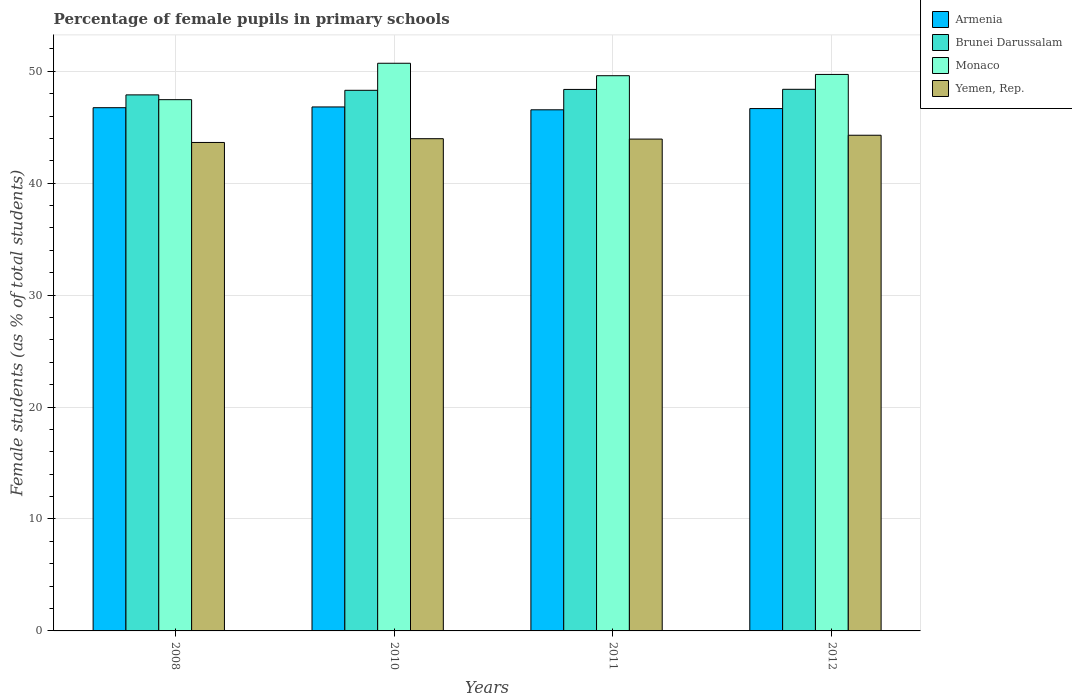How many different coloured bars are there?
Keep it short and to the point. 4. How many groups of bars are there?
Offer a very short reply. 4. Are the number of bars per tick equal to the number of legend labels?
Ensure brevity in your answer.  Yes. How many bars are there on the 4th tick from the left?
Give a very brief answer. 4. How many bars are there on the 3rd tick from the right?
Offer a terse response. 4. What is the label of the 4th group of bars from the left?
Your answer should be compact. 2012. In how many cases, is the number of bars for a given year not equal to the number of legend labels?
Offer a terse response. 0. What is the percentage of female pupils in primary schools in Yemen, Rep. in 2010?
Ensure brevity in your answer.  43.98. Across all years, what is the maximum percentage of female pupils in primary schools in Yemen, Rep.?
Your response must be concise. 44.28. Across all years, what is the minimum percentage of female pupils in primary schools in Monaco?
Offer a very short reply. 47.46. What is the total percentage of female pupils in primary schools in Yemen, Rep. in the graph?
Make the answer very short. 175.84. What is the difference between the percentage of female pupils in primary schools in Monaco in 2010 and that in 2011?
Ensure brevity in your answer.  1.11. What is the difference between the percentage of female pupils in primary schools in Yemen, Rep. in 2010 and the percentage of female pupils in primary schools in Brunei Darussalam in 2012?
Ensure brevity in your answer.  -4.41. What is the average percentage of female pupils in primary schools in Yemen, Rep. per year?
Provide a short and direct response. 43.96. In the year 2008, what is the difference between the percentage of female pupils in primary schools in Brunei Darussalam and percentage of female pupils in primary schools in Monaco?
Give a very brief answer. 0.43. In how many years, is the percentage of female pupils in primary schools in Monaco greater than 14 %?
Provide a short and direct response. 4. What is the ratio of the percentage of female pupils in primary schools in Yemen, Rep. in 2008 to that in 2012?
Give a very brief answer. 0.99. What is the difference between the highest and the second highest percentage of female pupils in primary schools in Monaco?
Give a very brief answer. 1. What is the difference between the highest and the lowest percentage of female pupils in primary schools in Brunei Darussalam?
Your answer should be very brief. 0.5. In how many years, is the percentage of female pupils in primary schools in Monaco greater than the average percentage of female pupils in primary schools in Monaco taken over all years?
Give a very brief answer. 3. What does the 4th bar from the left in 2011 represents?
Keep it short and to the point. Yemen, Rep. What does the 2nd bar from the right in 2011 represents?
Offer a very short reply. Monaco. Is it the case that in every year, the sum of the percentage of female pupils in primary schools in Armenia and percentage of female pupils in primary schools in Yemen, Rep. is greater than the percentage of female pupils in primary schools in Brunei Darussalam?
Your answer should be compact. Yes. How many bars are there?
Your answer should be compact. 16. Does the graph contain grids?
Provide a succinct answer. Yes. How are the legend labels stacked?
Keep it short and to the point. Vertical. What is the title of the graph?
Make the answer very short. Percentage of female pupils in primary schools. Does "Suriname" appear as one of the legend labels in the graph?
Ensure brevity in your answer.  No. What is the label or title of the Y-axis?
Your answer should be compact. Female students (as % of total students). What is the Female students (as % of total students) in Armenia in 2008?
Give a very brief answer. 46.74. What is the Female students (as % of total students) in Brunei Darussalam in 2008?
Offer a terse response. 47.89. What is the Female students (as % of total students) in Monaco in 2008?
Make the answer very short. 47.46. What is the Female students (as % of total students) of Yemen, Rep. in 2008?
Ensure brevity in your answer.  43.64. What is the Female students (as % of total students) of Armenia in 2010?
Offer a very short reply. 46.81. What is the Female students (as % of total students) in Brunei Darussalam in 2010?
Give a very brief answer. 48.3. What is the Female students (as % of total students) of Monaco in 2010?
Provide a short and direct response. 50.71. What is the Female students (as % of total students) in Yemen, Rep. in 2010?
Your response must be concise. 43.98. What is the Female students (as % of total students) in Armenia in 2011?
Give a very brief answer. 46.56. What is the Female students (as % of total students) in Brunei Darussalam in 2011?
Ensure brevity in your answer.  48.38. What is the Female students (as % of total students) in Monaco in 2011?
Ensure brevity in your answer.  49.6. What is the Female students (as % of total students) of Yemen, Rep. in 2011?
Keep it short and to the point. 43.94. What is the Female students (as % of total students) of Armenia in 2012?
Give a very brief answer. 46.67. What is the Female students (as % of total students) in Brunei Darussalam in 2012?
Offer a terse response. 48.39. What is the Female students (as % of total students) in Monaco in 2012?
Your response must be concise. 49.72. What is the Female students (as % of total students) in Yemen, Rep. in 2012?
Provide a short and direct response. 44.28. Across all years, what is the maximum Female students (as % of total students) in Armenia?
Your answer should be very brief. 46.81. Across all years, what is the maximum Female students (as % of total students) of Brunei Darussalam?
Provide a short and direct response. 48.39. Across all years, what is the maximum Female students (as % of total students) of Monaco?
Provide a succinct answer. 50.71. Across all years, what is the maximum Female students (as % of total students) of Yemen, Rep.?
Offer a very short reply. 44.28. Across all years, what is the minimum Female students (as % of total students) in Armenia?
Ensure brevity in your answer.  46.56. Across all years, what is the minimum Female students (as % of total students) of Brunei Darussalam?
Offer a terse response. 47.89. Across all years, what is the minimum Female students (as % of total students) in Monaco?
Ensure brevity in your answer.  47.46. Across all years, what is the minimum Female students (as % of total students) of Yemen, Rep.?
Give a very brief answer. 43.64. What is the total Female students (as % of total students) in Armenia in the graph?
Provide a succinct answer. 186.78. What is the total Female students (as % of total students) in Brunei Darussalam in the graph?
Your response must be concise. 192.95. What is the total Female students (as % of total students) of Monaco in the graph?
Your answer should be compact. 197.5. What is the total Female students (as % of total students) of Yemen, Rep. in the graph?
Provide a succinct answer. 175.84. What is the difference between the Female students (as % of total students) of Armenia in 2008 and that in 2010?
Ensure brevity in your answer.  -0.07. What is the difference between the Female students (as % of total students) of Brunei Darussalam in 2008 and that in 2010?
Make the answer very short. -0.41. What is the difference between the Female students (as % of total students) of Monaco in 2008 and that in 2010?
Keep it short and to the point. -3.25. What is the difference between the Female students (as % of total students) of Yemen, Rep. in 2008 and that in 2010?
Your response must be concise. -0.34. What is the difference between the Female students (as % of total students) of Armenia in 2008 and that in 2011?
Offer a terse response. 0.19. What is the difference between the Female students (as % of total students) of Brunei Darussalam in 2008 and that in 2011?
Keep it short and to the point. -0.49. What is the difference between the Female students (as % of total students) in Monaco in 2008 and that in 2011?
Keep it short and to the point. -2.14. What is the difference between the Female students (as % of total students) in Yemen, Rep. in 2008 and that in 2011?
Your answer should be compact. -0.3. What is the difference between the Female students (as % of total students) of Armenia in 2008 and that in 2012?
Give a very brief answer. 0.08. What is the difference between the Female students (as % of total students) of Brunei Darussalam in 2008 and that in 2012?
Your answer should be very brief. -0.5. What is the difference between the Female students (as % of total students) in Monaco in 2008 and that in 2012?
Make the answer very short. -2.25. What is the difference between the Female students (as % of total students) in Yemen, Rep. in 2008 and that in 2012?
Your answer should be compact. -0.65. What is the difference between the Female students (as % of total students) in Armenia in 2010 and that in 2011?
Your answer should be compact. 0.26. What is the difference between the Female students (as % of total students) in Brunei Darussalam in 2010 and that in 2011?
Your answer should be very brief. -0.08. What is the difference between the Female students (as % of total students) in Monaco in 2010 and that in 2011?
Keep it short and to the point. 1.11. What is the difference between the Female students (as % of total students) of Yemen, Rep. in 2010 and that in 2011?
Provide a succinct answer. 0.04. What is the difference between the Female students (as % of total students) in Armenia in 2010 and that in 2012?
Your answer should be compact. 0.15. What is the difference between the Female students (as % of total students) in Brunei Darussalam in 2010 and that in 2012?
Provide a short and direct response. -0.09. What is the difference between the Female students (as % of total students) in Yemen, Rep. in 2010 and that in 2012?
Provide a succinct answer. -0.31. What is the difference between the Female students (as % of total students) of Armenia in 2011 and that in 2012?
Offer a very short reply. -0.11. What is the difference between the Female students (as % of total students) in Brunei Darussalam in 2011 and that in 2012?
Provide a short and direct response. -0.01. What is the difference between the Female students (as % of total students) of Monaco in 2011 and that in 2012?
Give a very brief answer. -0.11. What is the difference between the Female students (as % of total students) of Yemen, Rep. in 2011 and that in 2012?
Provide a short and direct response. -0.34. What is the difference between the Female students (as % of total students) of Armenia in 2008 and the Female students (as % of total students) of Brunei Darussalam in 2010?
Your answer should be very brief. -1.55. What is the difference between the Female students (as % of total students) in Armenia in 2008 and the Female students (as % of total students) in Monaco in 2010?
Your response must be concise. -3.97. What is the difference between the Female students (as % of total students) of Armenia in 2008 and the Female students (as % of total students) of Yemen, Rep. in 2010?
Your answer should be very brief. 2.77. What is the difference between the Female students (as % of total students) of Brunei Darussalam in 2008 and the Female students (as % of total students) of Monaco in 2010?
Your response must be concise. -2.83. What is the difference between the Female students (as % of total students) in Brunei Darussalam in 2008 and the Female students (as % of total students) in Yemen, Rep. in 2010?
Offer a very short reply. 3.91. What is the difference between the Female students (as % of total students) in Monaco in 2008 and the Female students (as % of total students) in Yemen, Rep. in 2010?
Your answer should be very brief. 3.49. What is the difference between the Female students (as % of total students) of Armenia in 2008 and the Female students (as % of total students) of Brunei Darussalam in 2011?
Provide a succinct answer. -1.63. What is the difference between the Female students (as % of total students) in Armenia in 2008 and the Female students (as % of total students) in Monaco in 2011?
Make the answer very short. -2.86. What is the difference between the Female students (as % of total students) in Armenia in 2008 and the Female students (as % of total students) in Yemen, Rep. in 2011?
Make the answer very short. 2.8. What is the difference between the Female students (as % of total students) in Brunei Darussalam in 2008 and the Female students (as % of total students) in Monaco in 2011?
Give a very brief answer. -1.71. What is the difference between the Female students (as % of total students) in Brunei Darussalam in 2008 and the Female students (as % of total students) in Yemen, Rep. in 2011?
Provide a short and direct response. 3.95. What is the difference between the Female students (as % of total students) in Monaco in 2008 and the Female students (as % of total students) in Yemen, Rep. in 2011?
Provide a succinct answer. 3.52. What is the difference between the Female students (as % of total students) in Armenia in 2008 and the Female students (as % of total students) in Brunei Darussalam in 2012?
Ensure brevity in your answer.  -1.64. What is the difference between the Female students (as % of total students) in Armenia in 2008 and the Female students (as % of total students) in Monaco in 2012?
Make the answer very short. -2.97. What is the difference between the Female students (as % of total students) of Armenia in 2008 and the Female students (as % of total students) of Yemen, Rep. in 2012?
Your answer should be compact. 2.46. What is the difference between the Female students (as % of total students) of Brunei Darussalam in 2008 and the Female students (as % of total students) of Monaco in 2012?
Your response must be concise. -1.83. What is the difference between the Female students (as % of total students) of Brunei Darussalam in 2008 and the Female students (as % of total students) of Yemen, Rep. in 2012?
Make the answer very short. 3.61. What is the difference between the Female students (as % of total students) of Monaco in 2008 and the Female students (as % of total students) of Yemen, Rep. in 2012?
Your response must be concise. 3.18. What is the difference between the Female students (as % of total students) of Armenia in 2010 and the Female students (as % of total students) of Brunei Darussalam in 2011?
Provide a succinct answer. -1.57. What is the difference between the Female students (as % of total students) in Armenia in 2010 and the Female students (as % of total students) in Monaco in 2011?
Your response must be concise. -2.79. What is the difference between the Female students (as % of total students) in Armenia in 2010 and the Female students (as % of total students) in Yemen, Rep. in 2011?
Offer a terse response. 2.87. What is the difference between the Female students (as % of total students) of Brunei Darussalam in 2010 and the Female students (as % of total students) of Monaco in 2011?
Keep it short and to the point. -1.3. What is the difference between the Female students (as % of total students) in Brunei Darussalam in 2010 and the Female students (as % of total students) in Yemen, Rep. in 2011?
Keep it short and to the point. 4.36. What is the difference between the Female students (as % of total students) of Monaco in 2010 and the Female students (as % of total students) of Yemen, Rep. in 2011?
Your answer should be compact. 6.77. What is the difference between the Female students (as % of total students) of Armenia in 2010 and the Female students (as % of total students) of Brunei Darussalam in 2012?
Give a very brief answer. -1.58. What is the difference between the Female students (as % of total students) in Armenia in 2010 and the Female students (as % of total students) in Monaco in 2012?
Your answer should be very brief. -2.91. What is the difference between the Female students (as % of total students) in Armenia in 2010 and the Female students (as % of total students) in Yemen, Rep. in 2012?
Provide a succinct answer. 2.53. What is the difference between the Female students (as % of total students) of Brunei Darussalam in 2010 and the Female students (as % of total students) of Monaco in 2012?
Your answer should be compact. -1.42. What is the difference between the Female students (as % of total students) in Brunei Darussalam in 2010 and the Female students (as % of total students) in Yemen, Rep. in 2012?
Keep it short and to the point. 4.01. What is the difference between the Female students (as % of total students) in Monaco in 2010 and the Female students (as % of total students) in Yemen, Rep. in 2012?
Offer a very short reply. 6.43. What is the difference between the Female students (as % of total students) of Armenia in 2011 and the Female students (as % of total students) of Brunei Darussalam in 2012?
Give a very brief answer. -1.83. What is the difference between the Female students (as % of total students) in Armenia in 2011 and the Female students (as % of total students) in Monaco in 2012?
Provide a short and direct response. -3.16. What is the difference between the Female students (as % of total students) in Armenia in 2011 and the Female students (as % of total students) in Yemen, Rep. in 2012?
Your answer should be compact. 2.27. What is the difference between the Female students (as % of total students) in Brunei Darussalam in 2011 and the Female students (as % of total students) in Monaco in 2012?
Make the answer very short. -1.34. What is the difference between the Female students (as % of total students) in Brunei Darussalam in 2011 and the Female students (as % of total students) in Yemen, Rep. in 2012?
Offer a terse response. 4.09. What is the difference between the Female students (as % of total students) of Monaco in 2011 and the Female students (as % of total students) of Yemen, Rep. in 2012?
Your answer should be very brief. 5.32. What is the average Female students (as % of total students) of Armenia per year?
Offer a very short reply. 46.69. What is the average Female students (as % of total students) of Brunei Darussalam per year?
Keep it short and to the point. 48.24. What is the average Female students (as % of total students) of Monaco per year?
Keep it short and to the point. 49.37. What is the average Female students (as % of total students) of Yemen, Rep. per year?
Offer a terse response. 43.96. In the year 2008, what is the difference between the Female students (as % of total students) in Armenia and Female students (as % of total students) in Brunei Darussalam?
Your answer should be compact. -1.15. In the year 2008, what is the difference between the Female students (as % of total students) of Armenia and Female students (as % of total students) of Monaco?
Offer a terse response. -0.72. In the year 2008, what is the difference between the Female students (as % of total students) of Armenia and Female students (as % of total students) of Yemen, Rep.?
Provide a short and direct response. 3.11. In the year 2008, what is the difference between the Female students (as % of total students) in Brunei Darussalam and Female students (as % of total students) in Monaco?
Offer a very short reply. 0.43. In the year 2008, what is the difference between the Female students (as % of total students) of Brunei Darussalam and Female students (as % of total students) of Yemen, Rep.?
Ensure brevity in your answer.  4.25. In the year 2008, what is the difference between the Female students (as % of total students) of Monaco and Female students (as % of total students) of Yemen, Rep.?
Ensure brevity in your answer.  3.82. In the year 2010, what is the difference between the Female students (as % of total students) in Armenia and Female students (as % of total students) in Brunei Darussalam?
Ensure brevity in your answer.  -1.49. In the year 2010, what is the difference between the Female students (as % of total students) in Armenia and Female students (as % of total students) in Monaco?
Make the answer very short. -3.9. In the year 2010, what is the difference between the Female students (as % of total students) of Armenia and Female students (as % of total students) of Yemen, Rep.?
Your answer should be compact. 2.84. In the year 2010, what is the difference between the Female students (as % of total students) in Brunei Darussalam and Female students (as % of total students) in Monaco?
Make the answer very short. -2.42. In the year 2010, what is the difference between the Female students (as % of total students) in Brunei Darussalam and Female students (as % of total students) in Yemen, Rep.?
Your answer should be very brief. 4.32. In the year 2010, what is the difference between the Female students (as % of total students) in Monaco and Female students (as % of total students) in Yemen, Rep.?
Provide a short and direct response. 6.74. In the year 2011, what is the difference between the Female students (as % of total students) in Armenia and Female students (as % of total students) in Brunei Darussalam?
Ensure brevity in your answer.  -1.82. In the year 2011, what is the difference between the Female students (as % of total students) of Armenia and Female students (as % of total students) of Monaco?
Keep it short and to the point. -3.05. In the year 2011, what is the difference between the Female students (as % of total students) in Armenia and Female students (as % of total students) in Yemen, Rep.?
Offer a terse response. 2.62. In the year 2011, what is the difference between the Female students (as % of total students) in Brunei Darussalam and Female students (as % of total students) in Monaco?
Provide a succinct answer. -1.23. In the year 2011, what is the difference between the Female students (as % of total students) of Brunei Darussalam and Female students (as % of total students) of Yemen, Rep.?
Provide a short and direct response. 4.44. In the year 2011, what is the difference between the Female students (as % of total students) in Monaco and Female students (as % of total students) in Yemen, Rep.?
Give a very brief answer. 5.66. In the year 2012, what is the difference between the Female students (as % of total students) of Armenia and Female students (as % of total students) of Brunei Darussalam?
Make the answer very short. -1.72. In the year 2012, what is the difference between the Female students (as % of total students) in Armenia and Female students (as % of total students) in Monaco?
Keep it short and to the point. -3.05. In the year 2012, what is the difference between the Female students (as % of total students) in Armenia and Female students (as % of total students) in Yemen, Rep.?
Give a very brief answer. 2.38. In the year 2012, what is the difference between the Female students (as % of total students) of Brunei Darussalam and Female students (as % of total students) of Monaco?
Offer a terse response. -1.33. In the year 2012, what is the difference between the Female students (as % of total students) in Brunei Darussalam and Female students (as % of total students) in Yemen, Rep.?
Ensure brevity in your answer.  4.1. In the year 2012, what is the difference between the Female students (as % of total students) in Monaco and Female students (as % of total students) in Yemen, Rep.?
Ensure brevity in your answer.  5.43. What is the ratio of the Female students (as % of total students) in Armenia in 2008 to that in 2010?
Give a very brief answer. 1. What is the ratio of the Female students (as % of total students) of Brunei Darussalam in 2008 to that in 2010?
Provide a succinct answer. 0.99. What is the ratio of the Female students (as % of total students) of Monaco in 2008 to that in 2010?
Your answer should be very brief. 0.94. What is the ratio of the Female students (as % of total students) in Yemen, Rep. in 2008 to that in 2010?
Provide a succinct answer. 0.99. What is the ratio of the Female students (as % of total students) of Monaco in 2008 to that in 2011?
Your response must be concise. 0.96. What is the ratio of the Female students (as % of total students) of Armenia in 2008 to that in 2012?
Your answer should be very brief. 1. What is the ratio of the Female students (as % of total students) of Brunei Darussalam in 2008 to that in 2012?
Give a very brief answer. 0.99. What is the ratio of the Female students (as % of total students) in Monaco in 2008 to that in 2012?
Your response must be concise. 0.95. What is the ratio of the Female students (as % of total students) of Yemen, Rep. in 2008 to that in 2012?
Provide a succinct answer. 0.99. What is the ratio of the Female students (as % of total students) in Monaco in 2010 to that in 2011?
Ensure brevity in your answer.  1.02. What is the ratio of the Female students (as % of total students) in Armenia in 2010 to that in 2012?
Make the answer very short. 1. What is the ratio of the Female students (as % of total students) in Brunei Darussalam in 2010 to that in 2012?
Make the answer very short. 1. What is the ratio of the Female students (as % of total students) of Monaco in 2010 to that in 2012?
Make the answer very short. 1.02. What is the ratio of the Female students (as % of total students) in Yemen, Rep. in 2010 to that in 2012?
Provide a short and direct response. 0.99. What is the ratio of the Female students (as % of total students) in Brunei Darussalam in 2011 to that in 2012?
Your response must be concise. 1. What is the ratio of the Female students (as % of total students) of Monaco in 2011 to that in 2012?
Offer a terse response. 1. What is the ratio of the Female students (as % of total students) in Yemen, Rep. in 2011 to that in 2012?
Your response must be concise. 0.99. What is the difference between the highest and the second highest Female students (as % of total students) in Armenia?
Provide a short and direct response. 0.07. What is the difference between the highest and the second highest Female students (as % of total students) of Brunei Darussalam?
Keep it short and to the point. 0.01. What is the difference between the highest and the second highest Female students (as % of total students) of Monaco?
Provide a short and direct response. 1. What is the difference between the highest and the second highest Female students (as % of total students) of Yemen, Rep.?
Keep it short and to the point. 0.31. What is the difference between the highest and the lowest Female students (as % of total students) in Armenia?
Keep it short and to the point. 0.26. What is the difference between the highest and the lowest Female students (as % of total students) in Brunei Darussalam?
Your response must be concise. 0.5. What is the difference between the highest and the lowest Female students (as % of total students) in Monaco?
Provide a short and direct response. 3.25. What is the difference between the highest and the lowest Female students (as % of total students) of Yemen, Rep.?
Offer a terse response. 0.65. 